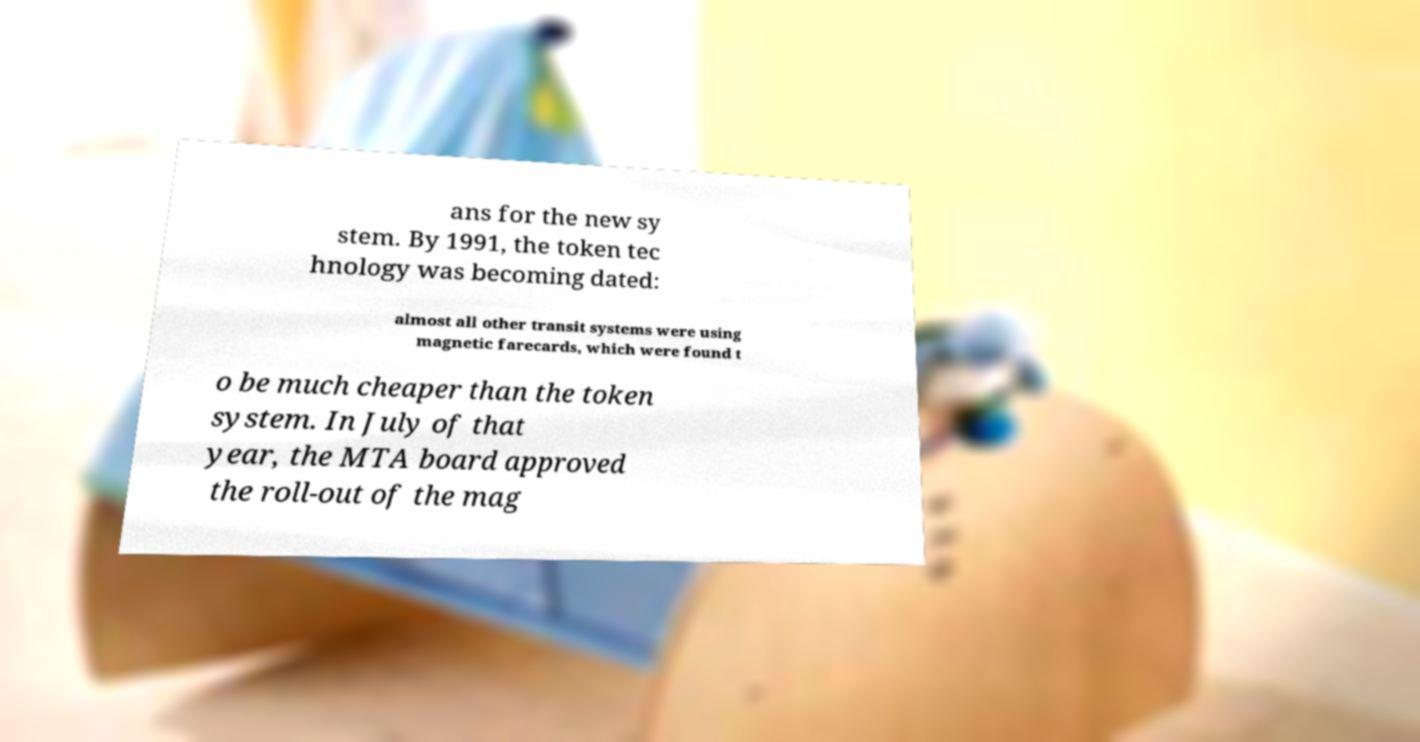What messages or text are displayed in this image? I need them in a readable, typed format. ans for the new sy stem. By 1991, the token tec hnology was becoming dated: almost all other transit systems were using magnetic farecards, which were found t o be much cheaper than the token system. In July of that year, the MTA board approved the roll-out of the mag 